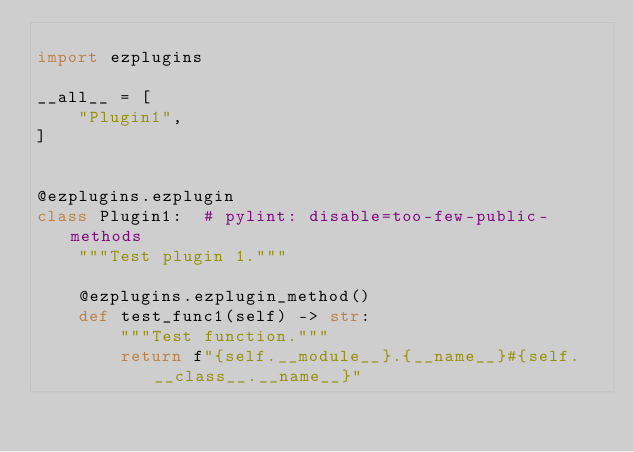Convert code to text. <code><loc_0><loc_0><loc_500><loc_500><_Python_>
import ezplugins

__all__ = [
    "Plugin1",
]


@ezplugins.ezplugin
class Plugin1:  # pylint: disable=too-few-public-methods
    """Test plugin 1."""

    @ezplugins.ezplugin_method()
    def test_func1(self) -> str:
        """Test function."""
        return f"{self.__module__}.{__name__}#{self.__class__.__name__}"
</code> 